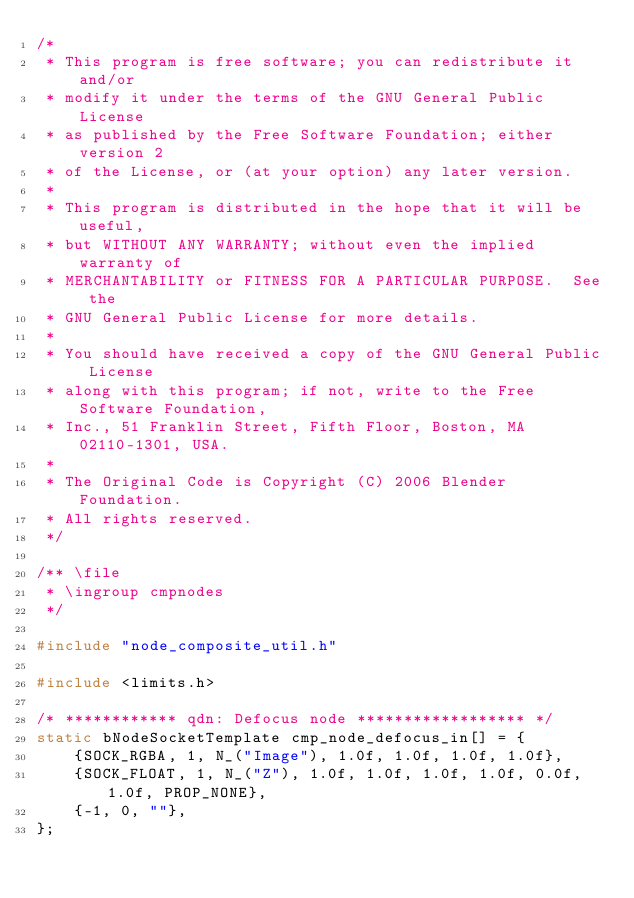<code> <loc_0><loc_0><loc_500><loc_500><_C_>/*
 * This program is free software; you can redistribute it and/or
 * modify it under the terms of the GNU General Public License
 * as published by the Free Software Foundation; either version 2
 * of the License, or (at your option) any later version.
 *
 * This program is distributed in the hope that it will be useful,
 * but WITHOUT ANY WARRANTY; without even the implied warranty of
 * MERCHANTABILITY or FITNESS FOR A PARTICULAR PURPOSE.  See the
 * GNU General Public License for more details.
 *
 * You should have received a copy of the GNU General Public License
 * along with this program; if not, write to the Free Software Foundation,
 * Inc., 51 Franklin Street, Fifth Floor, Boston, MA 02110-1301, USA.
 *
 * The Original Code is Copyright (C) 2006 Blender Foundation.
 * All rights reserved.
 */

/** \file
 * \ingroup cmpnodes
 */

#include "node_composite_util.h"

#include <limits.h>

/* ************ qdn: Defocus node ****************** */
static bNodeSocketTemplate cmp_node_defocus_in[] = {
    {SOCK_RGBA, 1, N_("Image"), 1.0f, 1.0f, 1.0f, 1.0f},
    {SOCK_FLOAT, 1, N_("Z"), 1.0f, 1.0f, 1.0f, 1.0f, 0.0f, 1.0f, PROP_NONE},
    {-1, 0, ""},
};</code> 